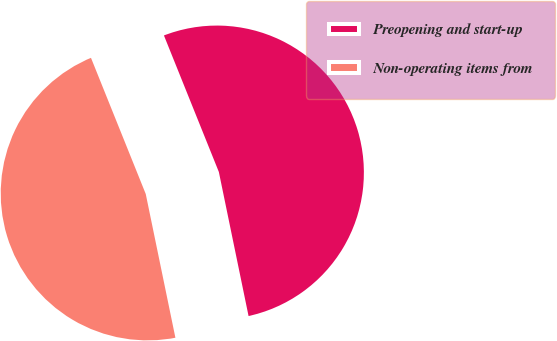Convert chart. <chart><loc_0><loc_0><loc_500><loc_500><pie_chart><fcel>Preopening and start-up<fcel>Non-operating items from<nl><fcel>52.85%<fcel>47.15%<nl></chart> 